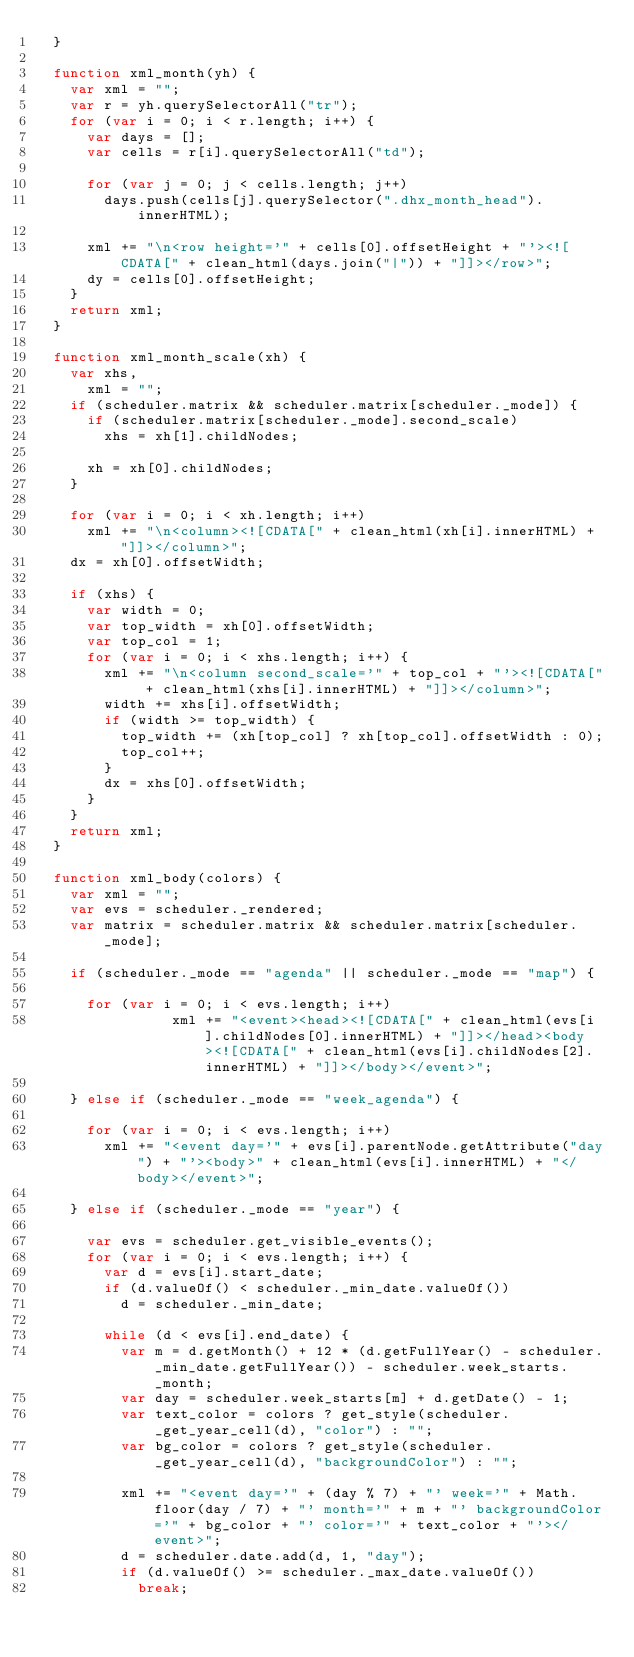Convert code to text. <code><loc_0><loc_0><loc_500><loc_500><_JavaScript_>	}

	function xml_month(yh) {
		var xml = "";
		var r = yh.querySelectorAll("tr");
		for (var i = 0; i < r.length; i++) {
			var days = [];
			var cells = r[i].querySelectorAll("td");

			for (var j = 0; j < cells.length; j++)
				days.push(cells[j].querySelector(".dhx_month_head").innerHTML);

			xml += "\n<row height='" + cells[0].offsetHeight + "'><![CDATA[" + clean_html(days.join("|")) + "]]></row>";
			dy = cells[0].offsetHeight;
		}
		return xml;
	}

	function xml_month_scale(xh) {
		var xhs,
			xml = "";
		if (scheduler.matrix && scheduler.matrix[scheduler._mode]) {
			if (scheduler.matrix[scheduler._mode].second_scale)
				xhs = xh[1].childNodes;

			xh = xh[0].childNodes;
		}

		for (var i = 0; i < xh.length; i++)
			xml += "\n<column><![CDATA[" + clean_html(xh[i].innerHTML) + "]]></column>";
		dx = xh[0].offsetWidth;

		if (xhs) {
			var width = 0;
			var top_width = xh[0].offsetWidth;
			var top_col = 1;
			for (var i = 0; i < xhs.length; i++) {
				xml += "\n<column second_scale='" + top_col + "'><![CDATA[" + clean_html(xhs[i].innerHTML) + "]]></column>";
				width += xhs[i].offsetWidth;
				if (width >= top_width) {
					top_width += (xh[top_col] ? xh[top_col].offsetWidth : 0);
					top_col++;
				}
				dx = xhs[0].offsetWidth;
			}
		}
		return xml;
	}

	function xml_body(colors) {
		var xml = "";
		var evs = scheduler._rendered;
		var matrix = scheduler.matrix && scheduler.matrix[scheduler._mode];

		if (scheduler._mode == "agenda" || scheduler._mode == "map") {

			for (var i = 0; i < evs.length; i++)
                xml += "<event><head><![CDATA[" + clean_html(evs[i].childNodes[0].innerHTML) + "]]></head><body><![CDATA[" + clean_html(evs[i].childNodes[2].innerHTML) + "]]></body></event>";

		} else if (scheduler._mode == "week_agenda") {

			for (var i = 0; i < evs.length; i++)
				xml += "<event day='" + evs[i].parentNode.getAttribute("day") + "'><body>" + clean_html(evs[i].innerHTML) + "</body></event>";

		} else if (scheduler._mode == "year") {

			var evs = scheduler.get_visible_events();
			for (var i = 0; i < evs.length; i++) {
				var d = evs[i].start_date;
				if (d.valueOf() < scheduler._min_date.valueOf())
					d = scheduler._min_date;

				while (d < evs[i].end_date) {
					var m = d.getMonth() + 12 * (d.getFullYear() - scheduler._min_date.getFullYear()) - scheduler.week_starts._month;
					var day = scheduler.week_starts[m] + d.getDate() - 1;
					var text_color = colors ? get_style(scheduler._get_year_cell(d), "color") : "";
					var bg_color = colors ? get_style(scheduler._get_year_cell(d), "backgroundColor") : "";

					xml += "<event day='" + (day % 7) + "' week='" + Math.floor(day / 7) + "' month='" + m + "' backgroundColor='" + bg_color + "' color='" + text_color + "'></event>";
					d = scheduler.date.add(d, 1, "day");
					if (d.valueOf() >= scheduler._max_date.valueOf())
						break;</code> 